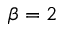Convert formula to latex. <formula><loc_0><loc_0><loc_500><loc_500>\beta = 2</formula> 